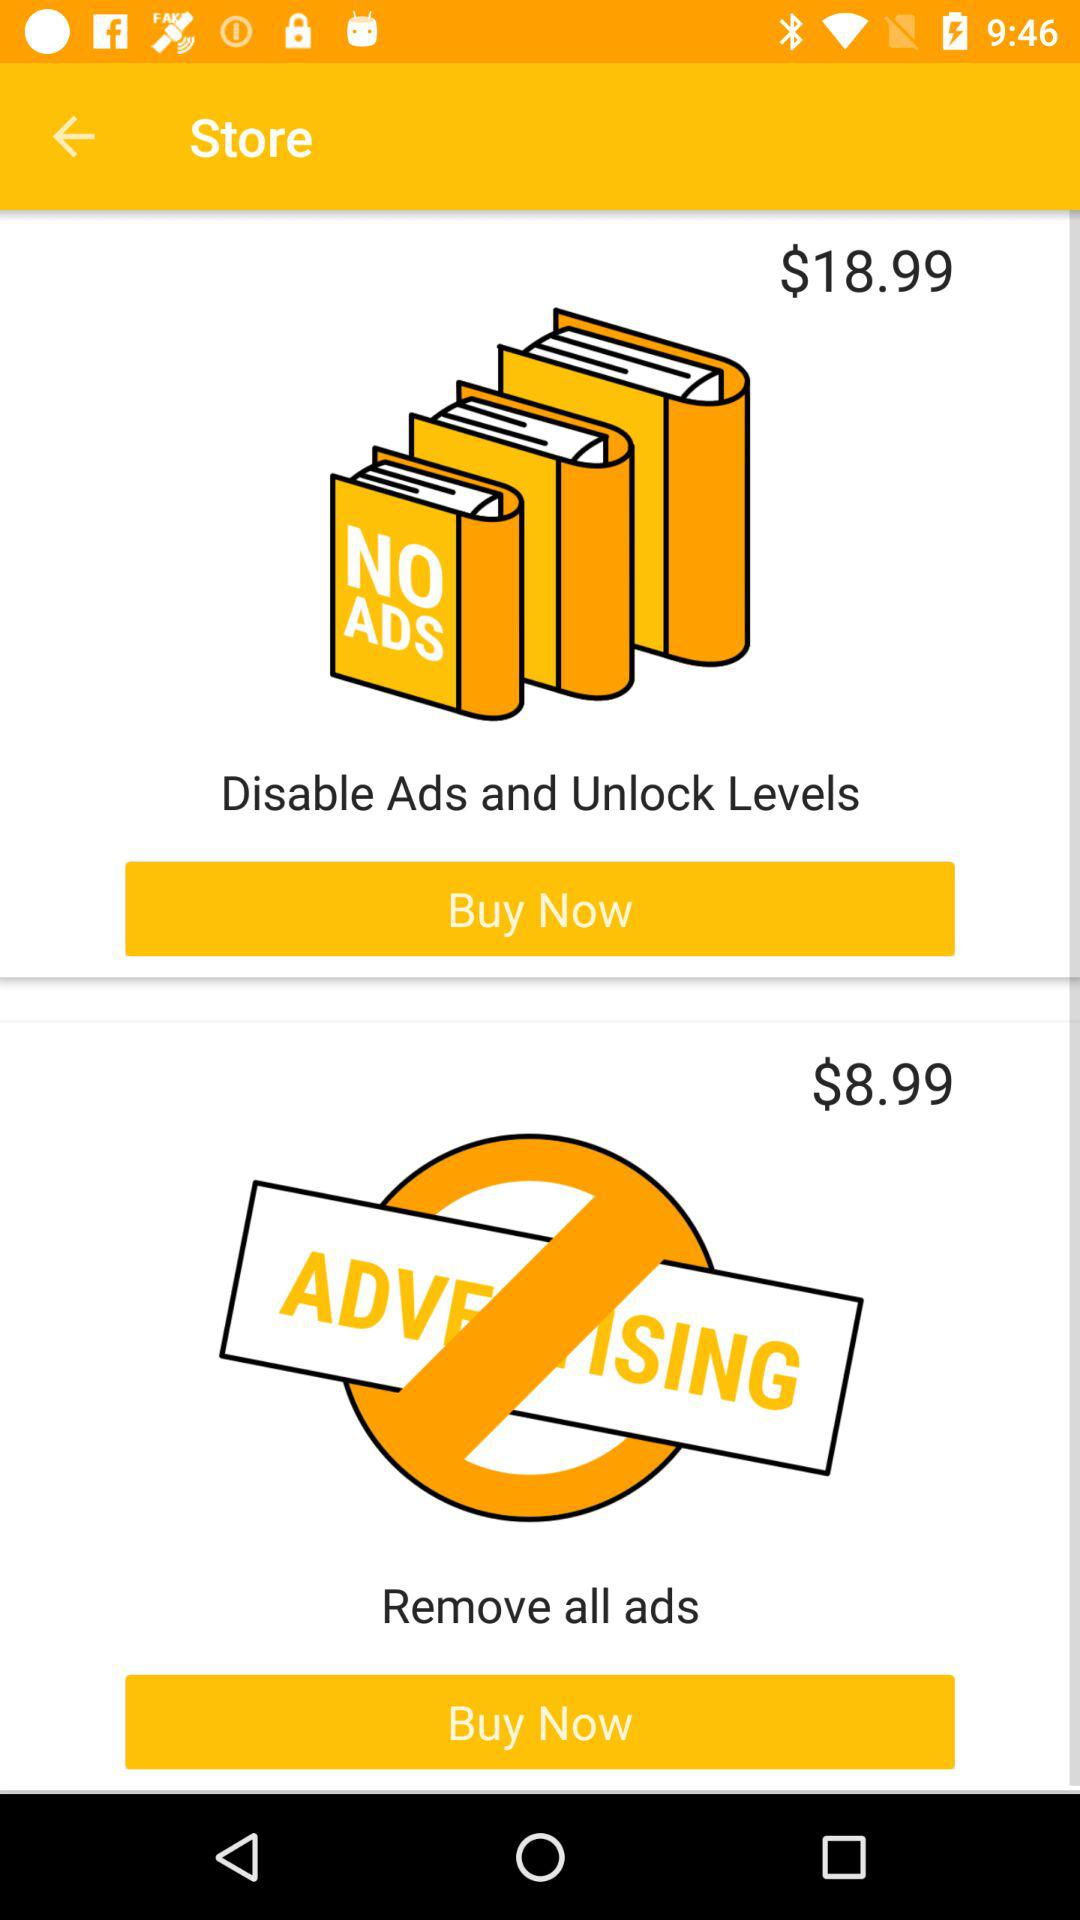What is the cost of removing all the ads? The cost is $8.99. 